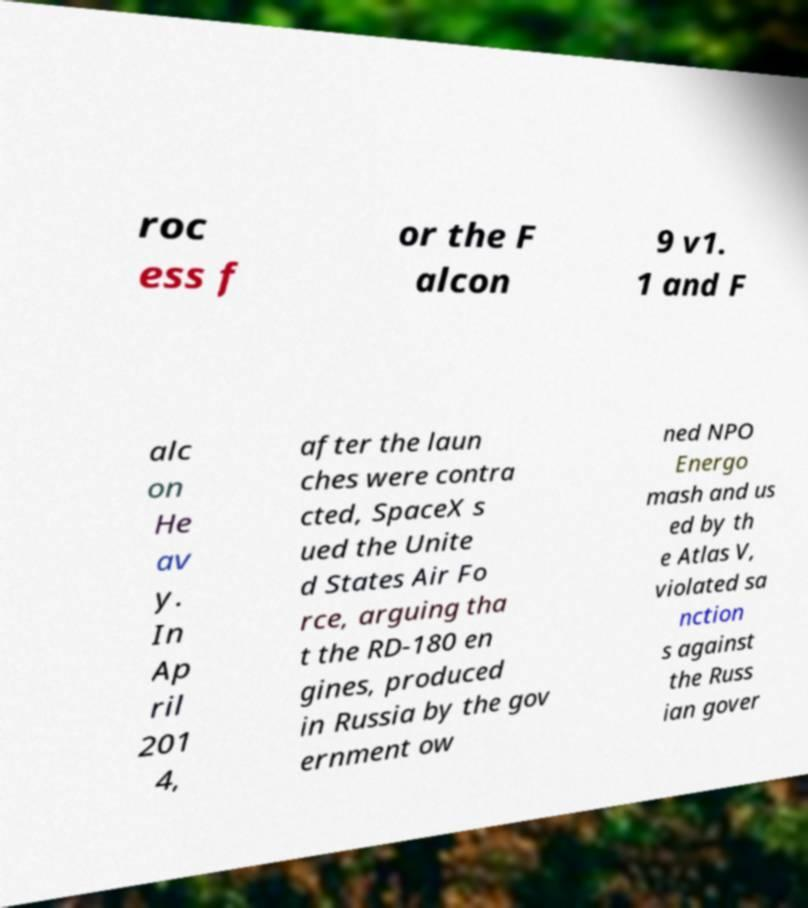Can you read and provide the text displayed in the image?This photo seems to have some interesting text. Can you extract and type it out for me? roc ess f or the F alcon 9 v1. 1 and F alc on He av y. In Ap ril 201 4, after the laun ches were contra cted, SpaceX s ued the Unite d States Air Fo rce, arguing tha t the RD-180 en gines, produced in Russia by the gov ernment ow ned NPO Energo mash and us ed by th e Atlas V, violated sa nction s against the Russ ian gover 